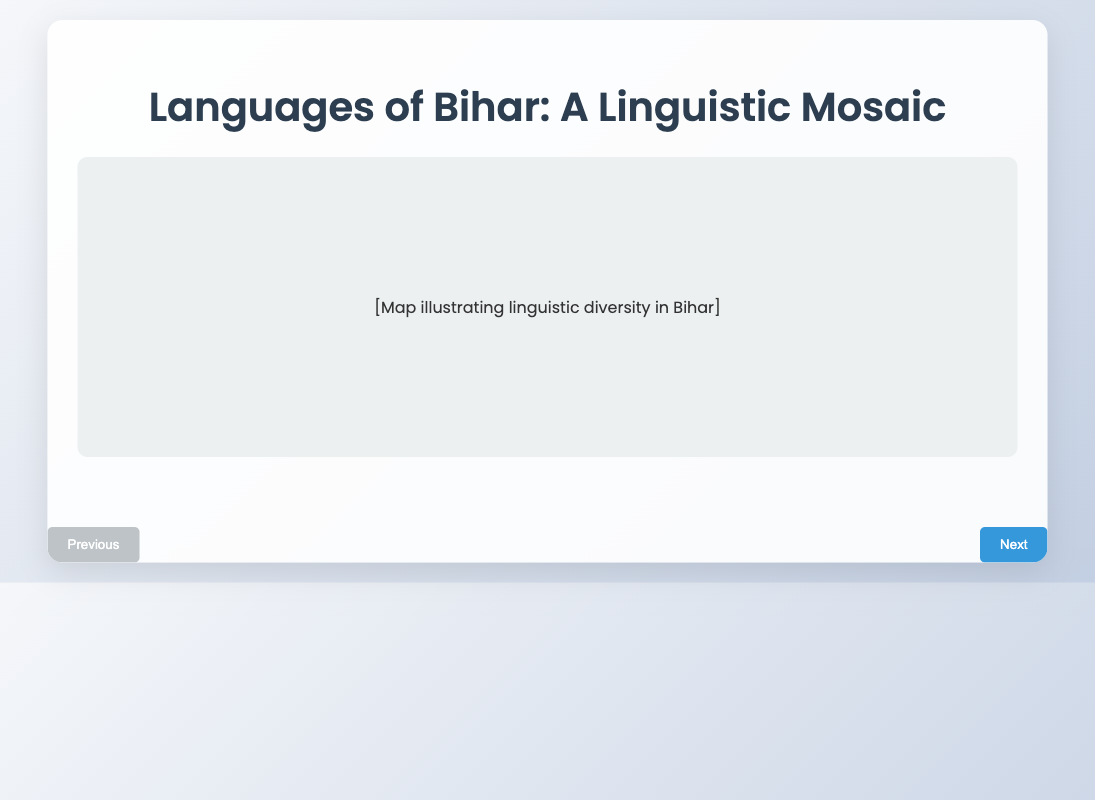What is the title of the presentation? The title is presented on the first slide.
Answer: Languages of Bihar: A Linguistic Mosaic Which script is traditionally used for Maithili? The information is provided in the comparison of languages.
Answer: Tirhuta What region is Bhojpuri spoken in? The answer can be found in slide 3 where languages and their regions are compared.
Answer: Western Bihar Who is a notable author associated with Magahi? The document includes notable works associated with each language.
Answer: Bhagwati Prasad In which script is Angika predominantly written now? This information is mentioned under the visual representation of script variations.
Answer: Devanagari What are the two languages discussed in terms of local cinema influence? This question requires recall of influence details from the content of the final slide.
Answer: Bhojpuri and Magahi On which slide is the historical evolution of major languages discussed? The slides are numbered, and the information can be found by identifying slide content.
Answer: Slide 2 What is the notable work of Maithili mentioned in the comparison? This detail comes from the same comparison table on slide 3.
Answer: Vidyapati's Poetry 